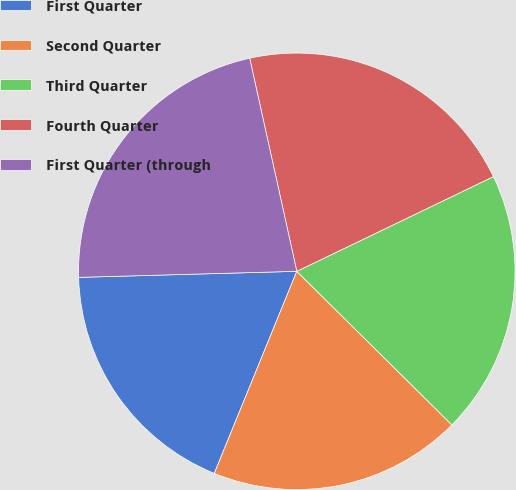Convert chart. <chart><loc_0><loc_0><loc_500><loc_500><pie_chart><fcel>First Quarter<fcel>Second Quarter<fcel>Third Quarter<fcel>Fourth Quarter<fcel>First Quarter (through<nl><fcel>18.39%<fcel>18.75%<fcel>19.57%<fcel>21.32%<fcel>21.98%<nl></chart> 